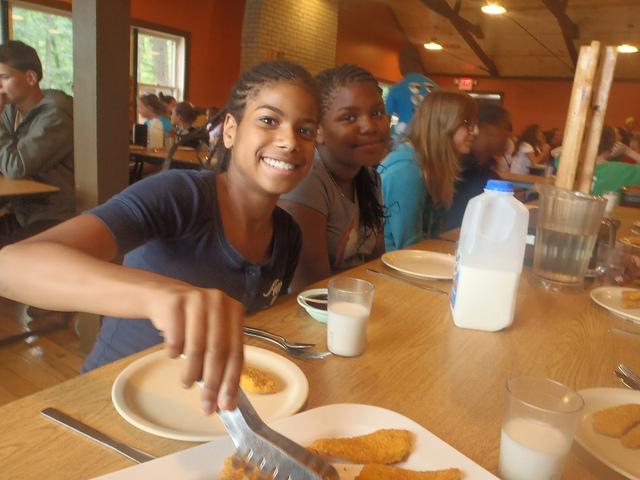What is she eating?
Answer briefly. Fish. What beverage does she have?
Write a very short answer. Milk. Is the hand left or right?
Answer briefly. Right. What is this person holding?
Keep it brief. Tongs. Are they drinking beer?
Keep it brief. No. What is being drank in this photo?
Short answer required. Milk. What color is the boys cup?
Be succinct. Clear. Does this look messy to eat?
Keep it brief. No. Are they drinking wine at the child's party?
Quick response, please. No. Is it day or night?
Short answer required. Day. How many kids are there?
Quick response, please. 4. Are they old?
Write a very short answer. No. What color is the customer's shirt?
Short answer required. Blue. Are these woman taking a cooking class?
Give a very brief answer. No. What is the girl eating?
Be succinct. Chicken. How many windows are in the scene?
Short answer required. 2. Is anyone wearing earrings?
Answer briefly. No. What is in the drinking glass in front of the girls?
Be succinct. Milk. What is in the glass?
Short answer required. Milk. Are there any bananas?
Short answer required. No. Which woman is smiling?
Short answer required. Left 1. 